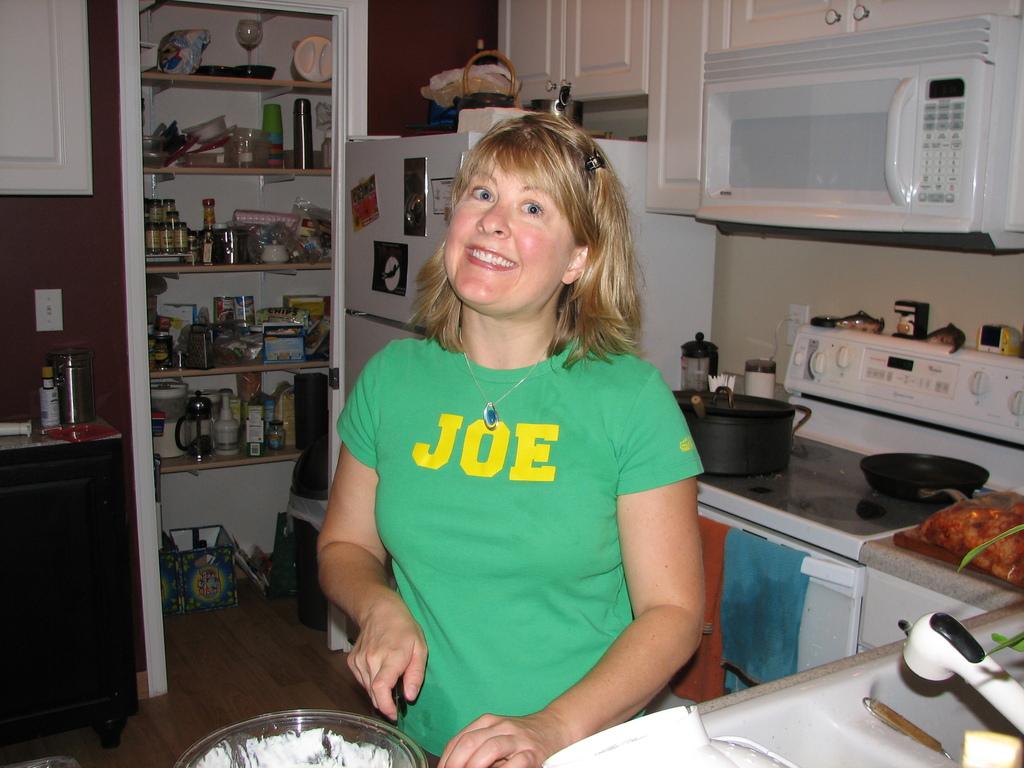What name does her shirt say?
Ensure brevity in your answer.  Joe. 